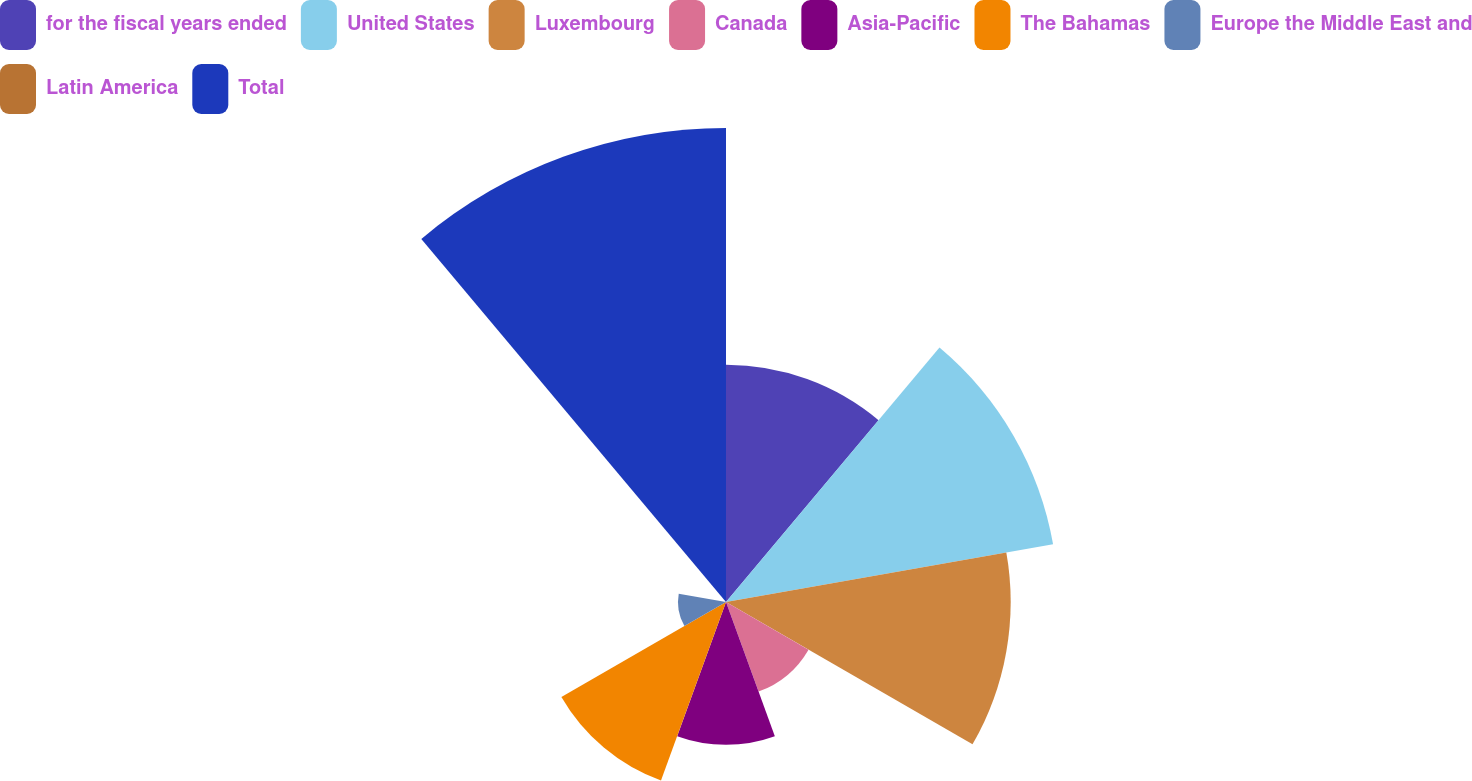<chart> <loc_0><loc_0><loc_500><loc_500><pie_chart><fcel>for the fiscal years ended<fcel>United States<fcel>Luxembourg<fcel>Canada<fcel>Asia-Pacific<fcel>The Bahamas<fcel>Europe the Middle East and<fcel>Latin America<fcel>Total<nl><fcel>13.15%<fcel>18.4%<fcel>15.77%<fcel>5.28%<fcel>7.91%<fcel>10.53%<fcel>2.66%<fcel>0.04%<fcel>26.26%<nl></chart> 